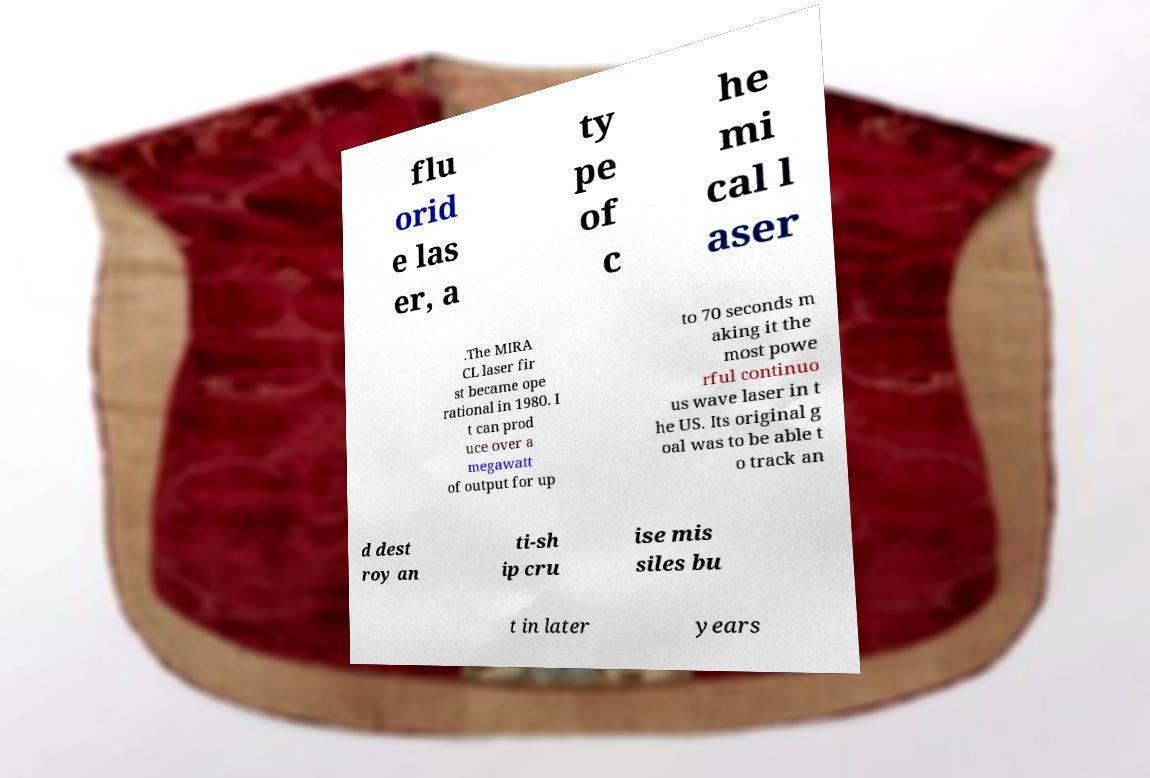Please read and relay the text visible in this image. What does it say? flu orid e las er, a ty pe of c he mi cal l aser .The MIRA CL laser fir st became ope rational in 1980. I t can prod uce over a megawatt of output for up to 70 seconds m aking it the most powe rful continuo us wave laser in t he US. Its original g oal was to be able t o track an d dest roy an ti-sh ip cru ise mis siles bu t in later years 